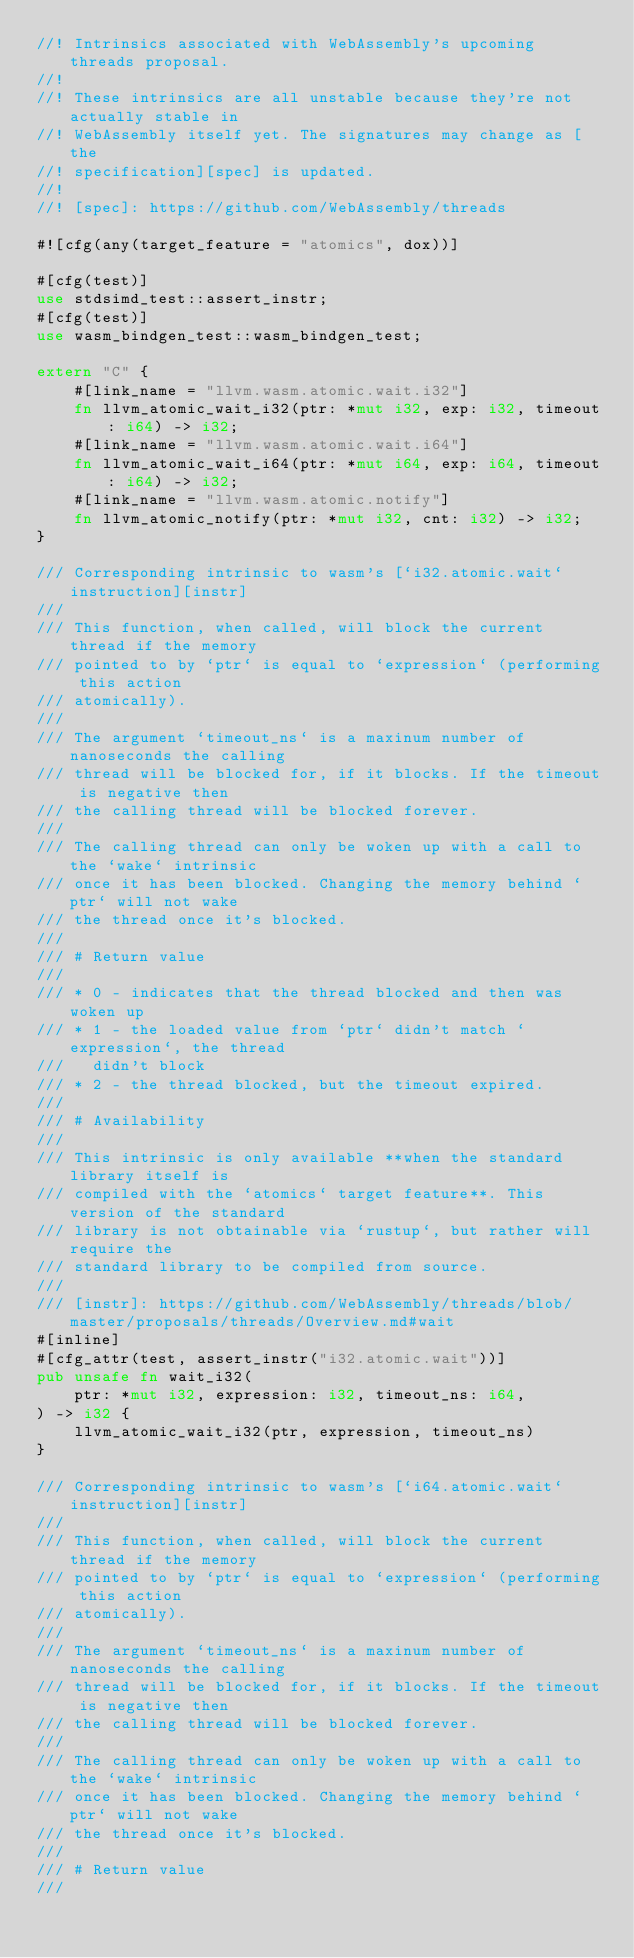Convert code to text. <code><loc_0><loc_0><loc_500><loc_500><_Rust_>//! Intrinsics associated with WebAssembly's upcoming threads proposal.
//!
//! These intrinsics are all unstable because they're not actually stable in
//! WebAssembly itself yet. The signatures may change as [the
//! specification][spec] is updated.
//!
//! [spec]: https://github.com/WebAssembly/threads

#![cfg(any(target_feature = "atomics", dox))]

#[cfg(test)]
use stdsimd_test::assert_instr;
#[cfg(test)]
use wasm_bindgen_test::wasm_bindgen_test;

extern "C" {
    #[link_name = "llvm.wasm.atomic.wait.i32"]
    fn llvm_atomic_wait_i32(ptr: *mut i32, exp: i32, timeout: i64) -> i32;
    #[link_name = "llvm.wasm.atomic.wait.i64"]
    fn llvm_atomic_wait_i64(ptr: *mut i64, exp: i64, timeout: i64) -> i32;
    #[link_name = "llvm.wasm.atomic.notify"]
    fn llvm_atomic_notify(ptr: *mut i32, cnt: i32) -> i32;
}

/// Corresponding intrinsic to wasm's [`i32.atomic.wait` instruction][instr]
///
/// This function, when called, will block the current thread if the memory
/// pointed to by `ptr` is equal to `expression` (performing this action
/// atomically).
///
/// The argument `timeout_ns` is a maxinum number of nanoseconds the calling
/// thread will be blocked for, if it blocks. If the timeout is negative then
/// the calling thread will be blocked forever.
///
/// The calling thread can only be woken up with a call to the `wake` intrinsic
/// once it has been blocked. Changing the memory behind `ptr` will not wake
/// the thread once it's blocked.
///
/// # Return value
///
/// * 0 - indicates that the thread blocked and then was woken up
/// * 1 - the loaded value from `ptr` didn't match `expression`, the thread
///   didn't block
/// * 2 - the thread blocked, but the timeout expired.
///
/// # Availability
///
/// This intrinsic is only available **when the standard library itself is
/// compiled with the `atomics` target feature**. This version of the standard
/// library is not obtainable via `rustup`, but rather will require the
/// standard library to be compiled from source.
///
/// [instr]: https://github.com/WebAssembly/threads/blob/master/proposals/threads/Overview.md#wait
#[inline]
#[cfg_attr(test, assert_instr("i32.atomic.wait"))]
pub unsafe fn wait_i32(
    ptr: *mut i32, expression: i32, timeout_ns: i64,
) -> i32 {
    llvm_atomic_wait_i32(ptr, expression, timeout_ns)
}

/// Corresponding intrinsic to wasm's [`i64.atomic.wait` instruction][instr]
///
/// This function, when called, will block the current thread if the memory
/// pointed to by `ptr` is equal to `expression` (performing this action
/// atomically).
///
/// The argument `timeout_ns` is a maxinum number of nanoseconds the calling
/// thread will be blocked for, if it blocks. If the timeout is negative then
/// the calling thread will be blocked forever.
///
/// The calling thread can only be woken up with a call to the `wake` intrinsic
/// once it has been blocked. Changing the memory behind `ptr` will not wake
/// the thread once it's blocked.
///
/// # Return value
///</code> 